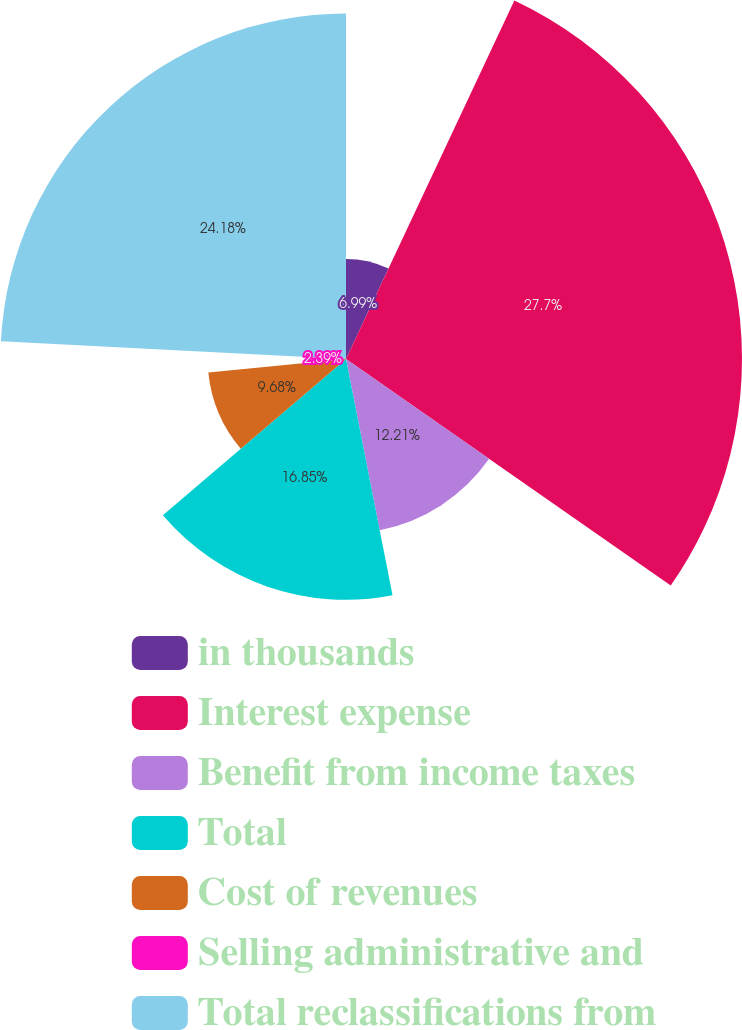<chart> <loc_0><loc_0><loc_500><loc_500><pie_chart><fcel>in thousands<fcel>Interest expense<fcel>Benefit from income taxes<fcel>Total<fcel>Cost of revenues<fcel>Selling administrative and<fcel>Total reclassifications from<nl><fcel>6.99%<fcel>27.71%<fcel>12.21%<fcel>16.85%<fcel>9.68%<fcel>2.39%<fcel>24.18%<nl></chart> 